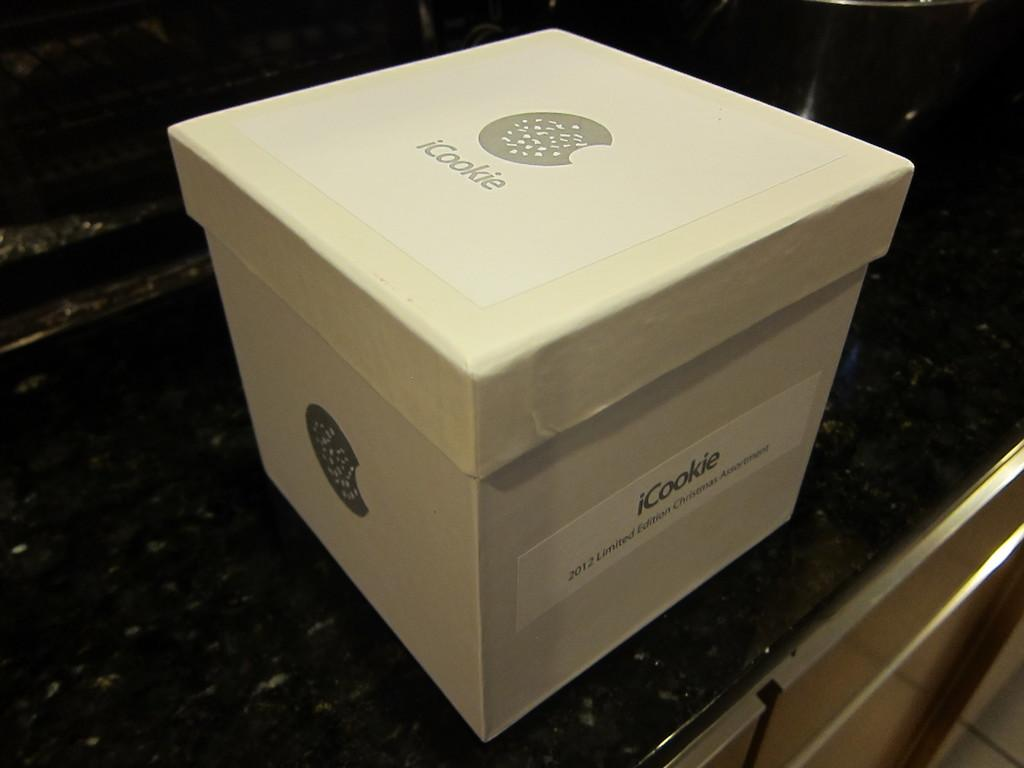Provide a one-sentence caption for the provided image. A white cardboard box from the company iCookie. 